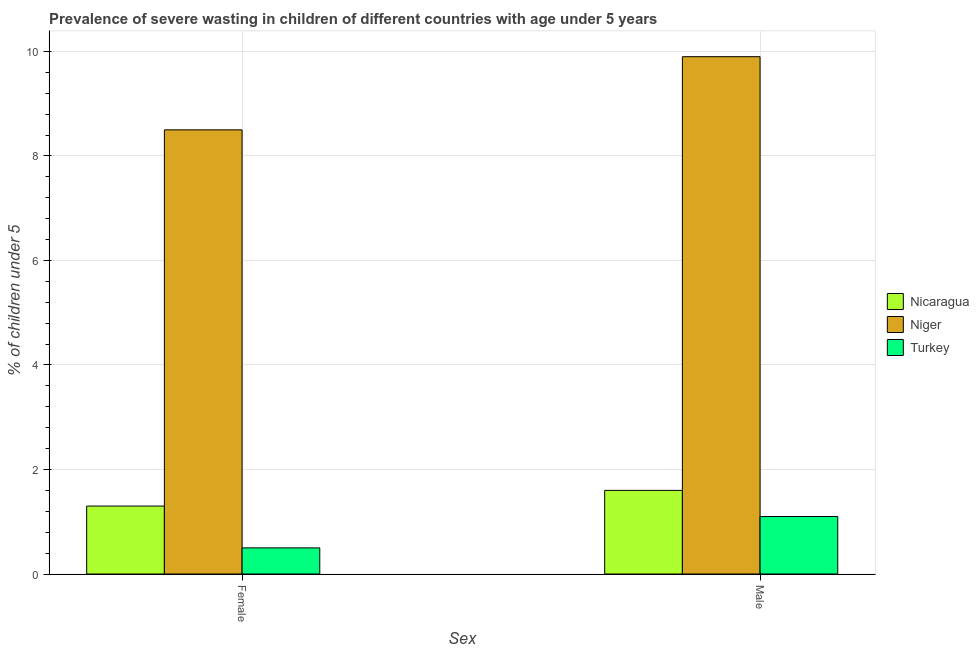What is the label of the 2nd group of bars from the left?
Ensure brevity in your answer.  Male. What is the percentage of undernourished male children in Turkey?
Provide a short and direct response. 1.1. Across all countries, what is the maximum percentage of undernourished female children?
Offer a very short reply. 8.5. In which country was the percentage of undernourished male children maximum?
Offer a very short reply. Niger. In which country was the percentage of undernourished female children minimum?
Your answer should be compact. Turkey. What is the total percentage of undernourished female children in the graph?
Offer a very short reply. 10.3. What is the difference between the percentage of undernourished female children in Turkey and that in Nicaragua?
Your answer should be very brief. -0.8. What is the difference between the percentage of undernourished female children in Turkey and the percentage of undernourished male children in Nicaragua?
Offer a terse response. -1.1. What is the average percentage of undernourished male children per country?
Your answer should be compact. 4.2. What is the difference between the percentage of undernourished female children and percentage of undernourished male children in Niger?
Your answer should be compact. -1.4. What is the ratio of the percentage of undernourished female children in Nicaragua to that in Turkey?
Provide a short and direct response. 2.6. Is the percentage of undernourished male children in Niger less than that in Nicaragua?
Offer a terse response. No. In how many countries, is the percentage of undernourished female children greater than the average percentage of undernourished female children taken over all countries?
Your answer should be very brief. 1. What does the 1st bar from the left in Female represents?
Offer a very short reply. Nicaragua. What does the 3rd bar from the right in Female represents?
Provide a succinct answer. Nicaragua. How many bars are there?
Ensure brevity in your answer.  6. What is the difference between two consecutive major ticks on the Y-axis?
Offer a terse response. 2. Where does the legend appear in the graph?
Offer a terse response. Center right. How are the legend labels stacked?
Provide a short and direct response. Vertical. What is the title of the graph?
Offer a very short reply. Prevalence of severe wasting in children of different countries with age under 5 years. What is the label or title of the X-axis?
Offer a terse response. Sex. What is the label or title of the Y-axis?
Your answer should be compact.  % of children under 5. What is the  % of children under 5 of Nicaragua in Female?
Make the answer very short. 1.3. What is the  % of children under 5 in Turkey in Female?
Offer a terse response. 0.5. What is the  % of children under 5 in Nicaragua in Male?
Provide a short and direct response. 1.6. What is the  % of children under 5 in Niger in Male?
Your response must be concise. 9.9. What is the  % of children under 5 in Turkey in Male?
Ensure brevity in your answer.  1.1. Across all Sex, what is the maximum  % of children under 5 in Nicaragua?
Give a very brief answer. 1.6. Across all Sex, what is the maximum  % of children under 5 in Niger?
Offer a terse response. 9.9. Across all Sex, what is the maximum  % of children under 5 in Turkey?
Provide a succinct answer. 1.1. Across all Sex, what is the minimum  % of children under 5 of Nicaragua?
Offer a very short reply. 1.3. What is the difference between the  % of children under 5 of Niger in Female and that in Male?
Keep it short and to the point. -1.4. What is the difference between the  % of children under 5 of Turkey in Female and that in Male?
Make the answer very short. -0.6. What is the difference between the  % of children under 5 of Nicaragua in Female and the  % of children under 5 of Niger in Male?
Ensure brevity in your answer.  -8.6. What is the difference between the  % of children under 5 of Nicaragua in Female and the  % of children under 5 of Turkey in Male?
Offer a very short reply. 0.2. What is the average  % of children under 5 in Nicaragua per Sex?
Make the answer very short. 1.45. What is the difference between the  % of children under 5 in Niger and  % of children under 5 in Turkey in Female?
Your answer should be very brief. 8. What is the difference between the  % of children under 5 of Nicaragua and  % of children under 5 of Turkey in Male?
Your response must be concise. 0.5. What is the difference between the  % of children under 5 in Niger and  % of children under 5 in Turkey in Male?
Offer a terse response. 8.8. What is the ratio of the  % of children under 5 in Nicaragua in Female to that in Male?
Your answer should be very brief. 0.81. What is the ratio of the  % of children under 5 of Niger in Female to that in Male?
Keep it short and to the point. 0.86. What is the ratio of the  % of children under 5 of Turkey in Female to that in Male?
Give a very brief answer. 0.45. What is the difference between the highest and the second highest  % of children under 5 in Niger?
Ensure brevity in your answer.  1.4. What is the difference between the highest and the second highest  % of children under 5 of Turkey?
Provide a short and direct response. 0.6. 